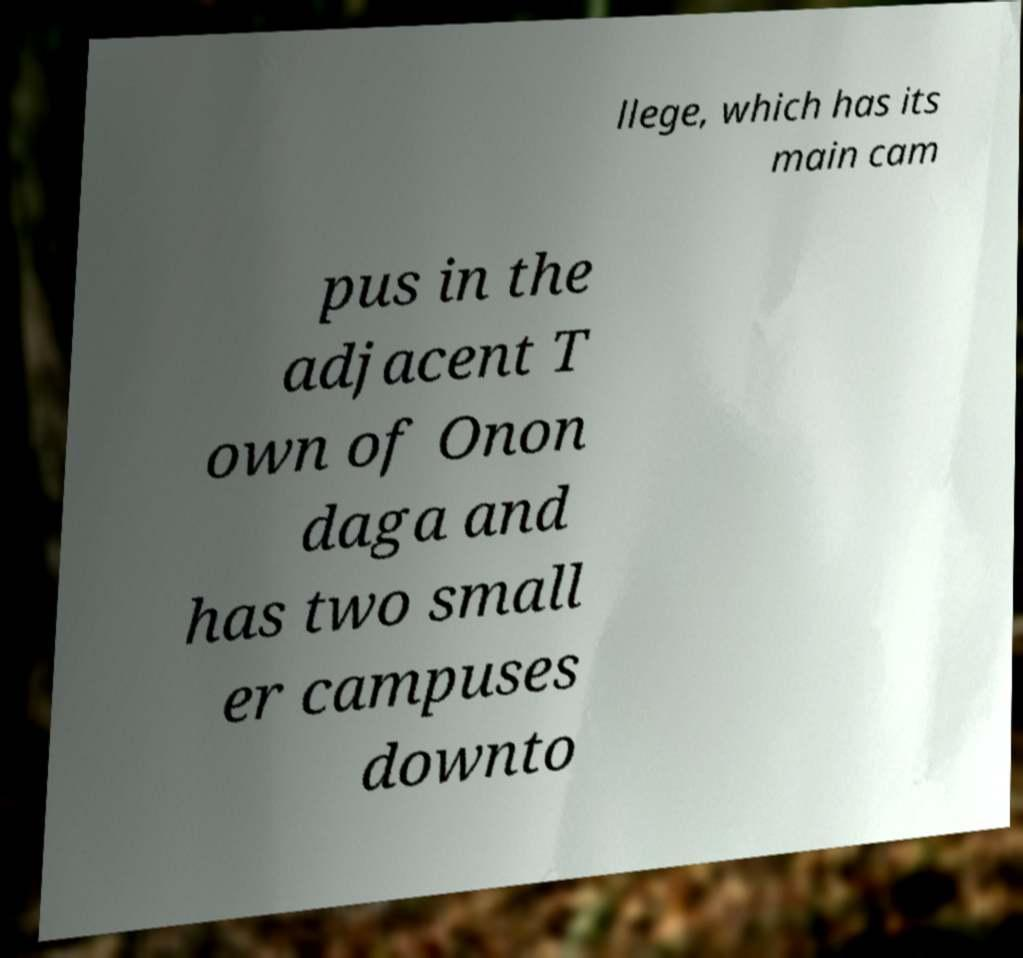For documentation purposes, I need the text within this image transcribed. Could you provide that? llege, which has its main cam pus in the adjacent T own of Onon daga and has two small er campuses downto 